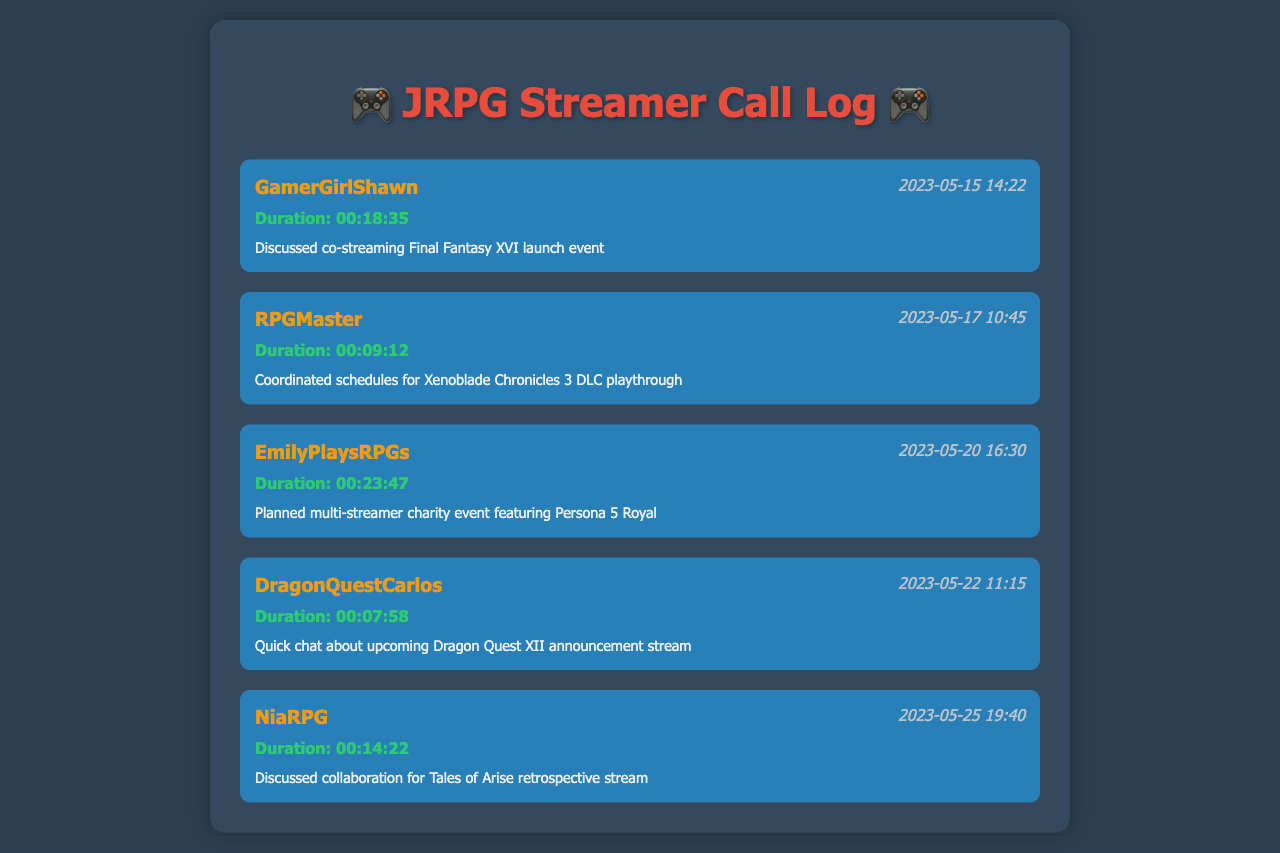What was the duration of the call with GamerGirlShawn? The duration of the call with GamerGirlShawn is provided in the call entry, which shows 00:18:35.
Answer: 00:18:35 When did the call with RPGMaster take place? The call entry for RPGMaster lists the date and time as 2023-05-17 10:45.
Answer: 2023-05-17 10:45 What was discussed during the call with EmilyPlaysRPGs? The notes section for EmilyPlaysRPGs indicates that they planned a multi-streamer charity event featuring Persona 5 Royal.
Answer: Multi-streamer charity event featuring Persona 5 Royal Who is the contact for the call on May 22, 2023? The call entry for May 22, 2023, lists DragonQuestCarlos as the contact.
Answer: DragonQuestCarlos How long was the call with NiaRPG? The duration mentioned in the call entry shows that the call with NiaRPG lasted for 00:14:22.
Answer: 00:14:22 What event was discussed in the call with GamerGirlShawn? The notes for the call with GamerGirlShawn specify that they discussed co-streaming the Final Fantasy XVI launch event.
Answer: Co-streaming Final Fantasy XVI launch event What was the primary reason for the call with DragonQuestCarlos? The notes indicate that the primary reason for the call was a quick chat about the upcoming Dragon Quest XII announcement stream.
Answer: Upcoming Dragon Quest XII announcement stream Which two streamers are involved in the multi-streamer charity event? The call with EmilyPlaysRPGs is focused on organizing the charity event, hence it involves her and possibly others associated with it.
Answer: EmilyPlaysRPGs and others 